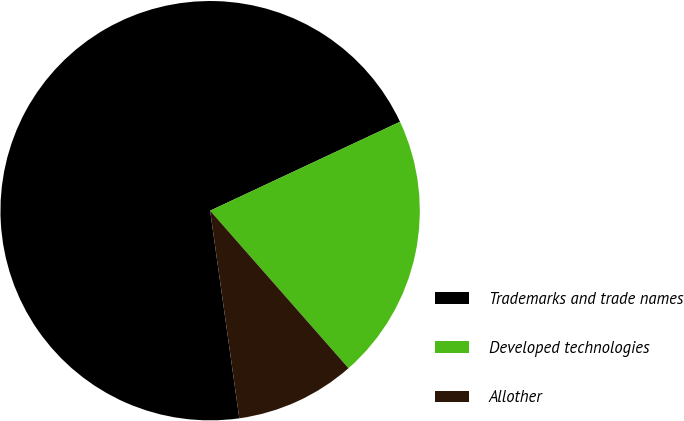<chart> <loc_0><loc_0><loc_500><loc_500><pie_chart><fcel>Trademarks and trade names<fcel>Developed technologies<fcel>Allother<nl><fcel>70.26%<fcel>20.5%<fcel>9.25%<nl></chart> 